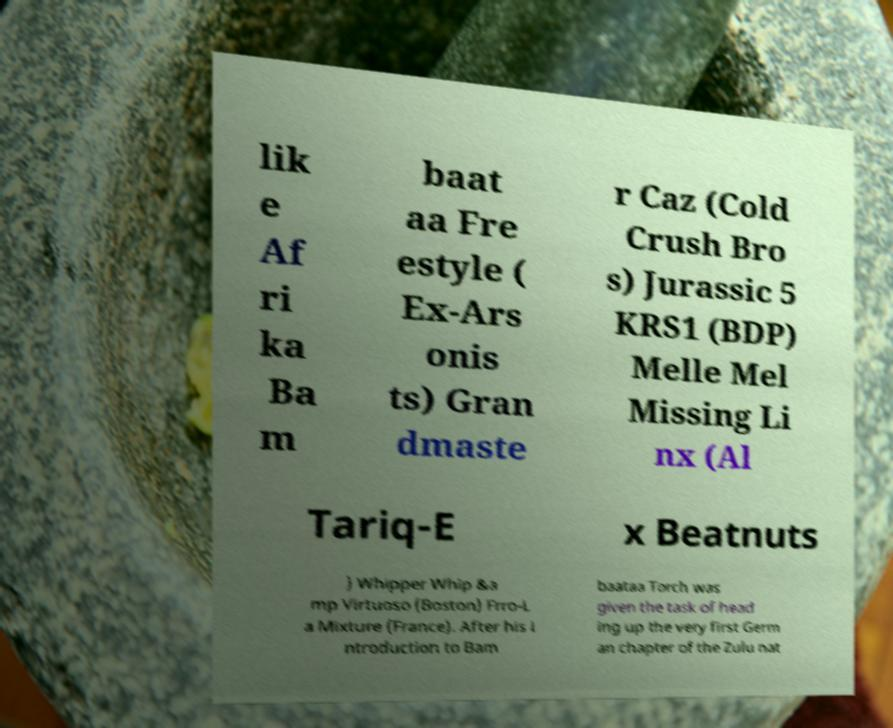What messages or text are displayed in this image? I need them in a readable, typed format. lik e Af ri ka Ba m baat aa Fre estyle ( Ex-Ars onis ts) Gran dmaste r Caz (Cold Crush Bro s) Jurassic 5 KRS1 (BDP) Melle Mel Missing Li nx (Al Tariq-E x Beatnuts ) Whipper Whip &a mp Virtuoso (Boston) Frro-L a Mixture (France). After his i ntroduction to Bam baataa Torch was given the task of head ing up the very first Germ an chapter of the Zulu nat 